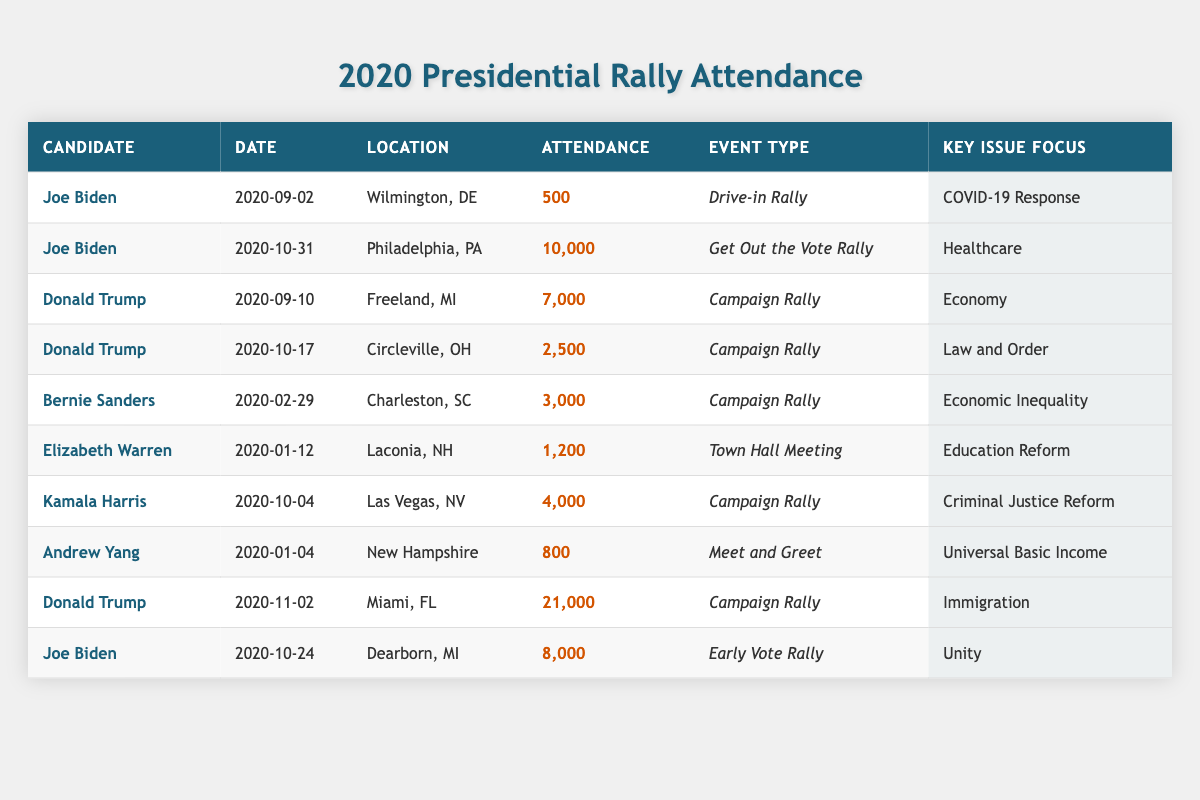What was the highest attendance at a rally for Joe Biden? Looking at the table, Joe Biden's rallies show attendance figures of 500, 10,000, 8,000. The highest value among these is 10,000.
Answer: 10,000 How many people attended Donald Trump's rally on November 2, 2020? The table specifically lists Donald Trump's rally on November 2, 2020, with an attendance figure of 21,000.
Answer: 21,000 What type of event was held by Kamala Harris on October 4, 2020? The event type for Kamala Harris on October 4, 2020, is categorized as a "Campaign Rally," as indicated in the table.
Answer: Campaign Rally Which candidate focused on "Education Reform" and what was their attendance? Elizabeth Warren was focused on "Education Reform" during her "Town Hall Meeting," which had an attendance of 1,200, as seen in the table.
Answer: Elizabeth Warren, 1,200 What is the total attendance for all rallies held by Joe Biden? Joe Biden's rally attendances were 500, 10,000, and 8,000. Adding these together gives: 500 + 10,000 + 8,000 = 18,500.
Answer: 18,500 Did Bernie Sanders have a rally more attended than Donald Trump's rally on October 17, 2020? Bernie Sanders' rally had an attendance of 3,000, while Donald Trump's rally on October 17 had an attendance of 2,500. Since 3,000 is greater than 2,500, the answer is yes.
Answer: Yes What was the average attendance for Donald Trump's rallies? Donald Trump's rallies had attendances of 7,000, 2,500, and 21,000. Calculating the average: (7,000 + 2,500 + 21,000) / 3 = 10,166.67.
Answer: 10,166.67 How many campaigns focused on the economy? The table shows two rallies focusing on the economy: one by Donald Trump and one by Bernie Sanders. This means there are 2 such rallies.
Answer: 2 Which event had the lowest attendance and what was the attendance figure? From the table, the lowest attendance figure is 500 for Joe Biden's "Drive-in Rally" on September 2, 2020.
Answer: 500 What was the attendance difference between Joe Biden's rallies in Philadelphia and Dearborn? The Philadelphia rally had 10,000 attendees and Dearborn had 8,000. The difference is 10,000 - 8,000 = 2,000.
Answer: 2,000 Which candidate had the highest rally attendance overall and what was the figure? Upon examining the table, Donald Trump had the highest rally attendance with 21,000 at his event in Miami.
Answer: Donald Trump, 21,000 